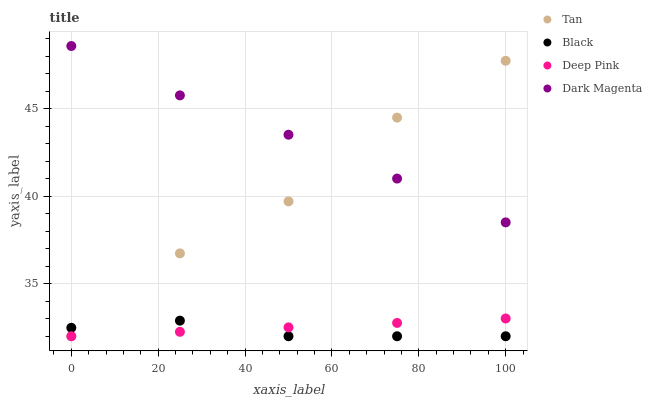Does Black have the minimum area under the curve?
Answer yes or no. Yes. Does Dark Magenta have the maximum area under the curve?
Answer yes or no. Yes. Does Deep Pink have the minimum area under the curve?
Answer yes or no. No. Does Deep Pink have the maximum area under the curve?
Answer yes or no. No. Is Deep Pink the smoothest?
Answer yes or no. Yes. Is Tan the roughest?
Answer yes or no. Yes. Is Black the smoothest?
Answer yes or no. No. Is Black the roughest?
Answer yes or no. No. Does Tan have the lowest value?
Answer yes or no. Yes. Does Dark Magenta have the lowest value?
Answer yes or no. No. Does Dark Magenta have the highest value?
Answer yes or no. Yes. Does Deep Pink have the highest value?
Answer yes or no. No. Is Deep Pink less than Dark Magenta?
Answer yes or no. Yes. Is Dark Magenta greater than Black?
Answer yes or no. Yes. Does Black intersect Tan?
Answer yes or no. Yes. Is Black less than Tan?
Answer yes or no. No. Is Black greater than Tan?
Answer yes or no. No. Does Deep Pink intersect Dark Magenta?
Answer yes or no. No. 